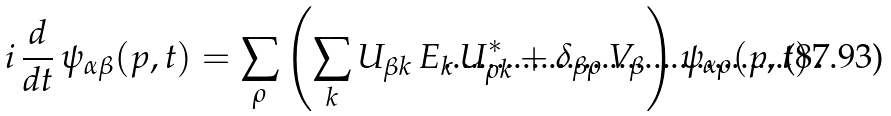Convert formula to latex. <formula><loc_0><loc_0><loc_500><loc_500>i \, \frac { \text {d} } { \text {d} t } \, \psi _ { \alpha \beta } ( p , t ) = \sum _ { \rho } \left ( \sum _ { k } U _ { \beta k } \, E _ { k } \, U _ { \rho k } ^ { * } + \delta _ { \beta \rho } \, V _ { \beta } \right ) \psi _ { \alpha \rho } ( p , t ) \, .</formula> 